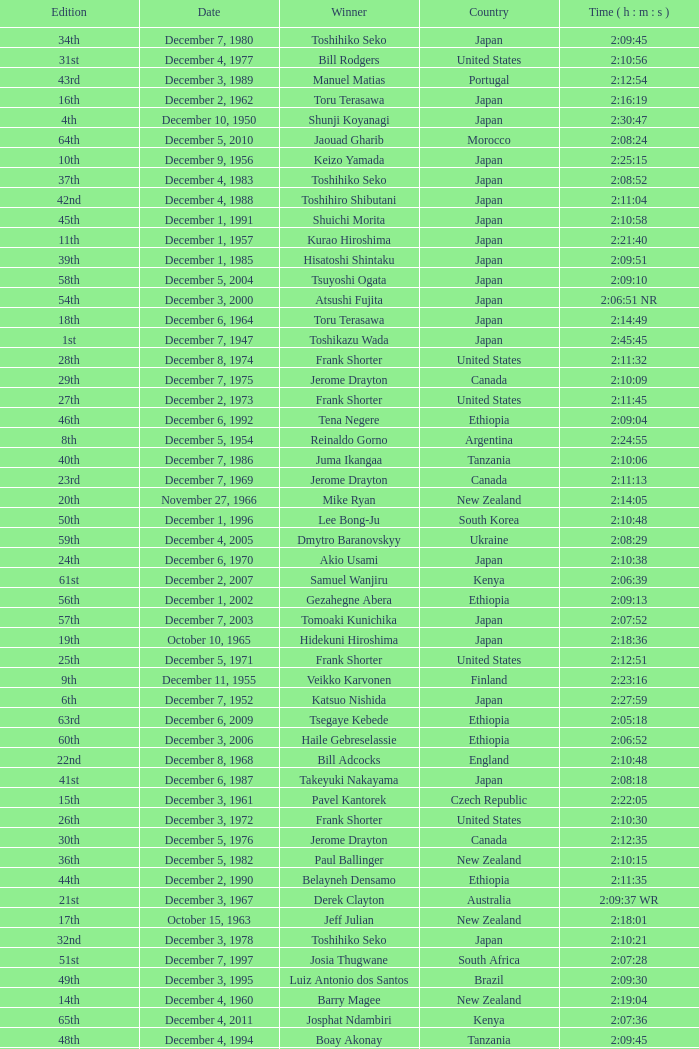On what date did Lee Bong-Ju win in 2:10:48? December 1, 1996. 